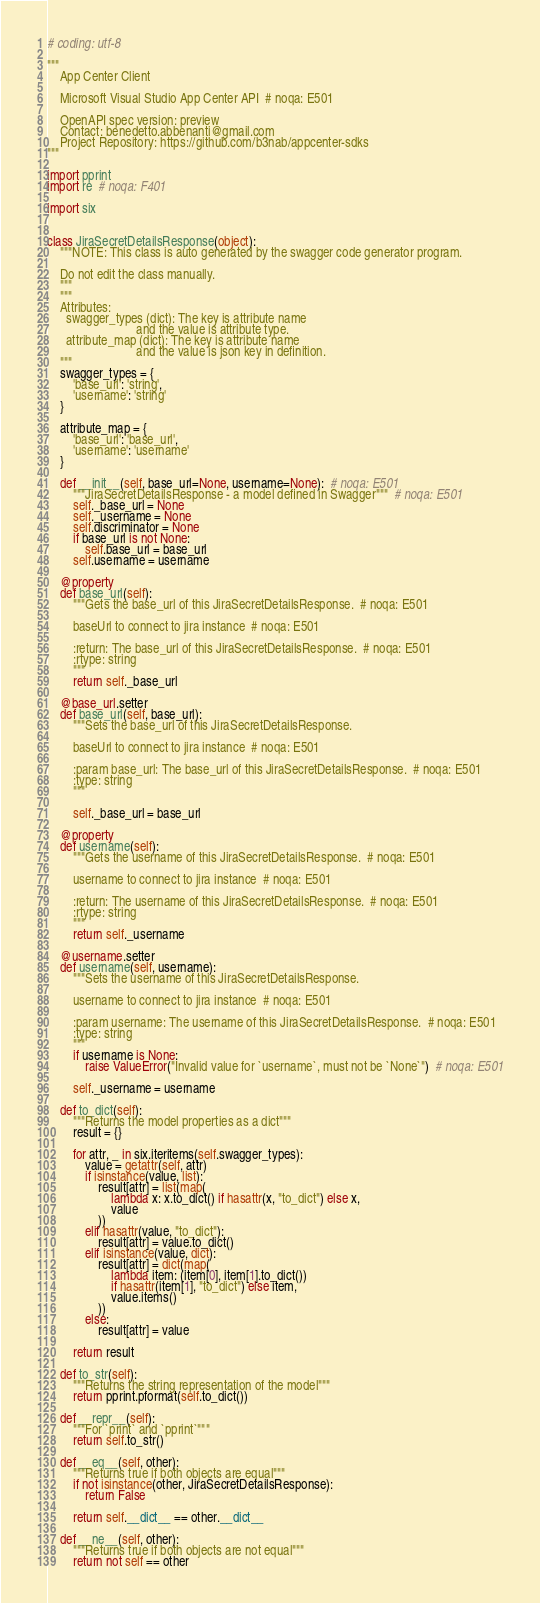<code> <loc_0><loc_0><loc_500><loc_500><_Python_># coding: utf-8

"""
    App Center Client

    Microsoft Visual Studio App Center API  # noqa: E501

    OpenAPI spec version: preview
    Contact: benedetto.abbenanti@gmail.com
    Project Repository: https://github.com/b3nab/appcenter-sdks
"""

import pprint
import re  # noqa: F401

import six


class JiraSecretDetailsResponse(object):
    """NOTE: This class is auto generated by the swagger code generator program.

    Do not edit the class manually.
    """
    """
    Attributes:
      swagger_types (dict): The key is attribute name
                            and the value is attribute type.
      attribute_map (dict): The key is attribute name
                            and the value is json key in definition.
    """
    swagger_types = {
        'base_url': 'string',
        'username': 'string'
    }

    attribute_map = {
        'base_url': 'base_url',
        'username': 'username'
    }

    def __init__(self, base_url=None, username=None):  # noqa: E501
        """JiraSecretDetailsResponse - a model defined in Swagger"""  # noqa: E501
        self._base_url = None
        self._username = None
        self.discriminator = None
        if base_url is not None:
            self.base_url = base_url
        self.username = username

    @property
    def base_url(self):
        """Gets the base_url of this JiraSecretDetailsResponse.  # noqa: E501

        baseUrl to connect to jira instance  # noqa: E501

        :return: The base_url of this JiraSecretDetailsResponse.  # noqa: E501
        :rtype: string
        """
        return self._base_url

    @base_url.setter
    def base_url(self, base_url):
        """Sets the base_url of this JiraSecretDetailsResponse.

        baseUrl to connect to jira instance  # noqa: E501

        :param base_url: The base_url of this JiraSecretDetailsResponse.  # noqa: E501
        :type: string
        """

        self._base_url = base_url

    @property
    def username(self):
        """Gets the username of this JiraSecretDetailsResponse.  # noqa: E501

        username to connect to jira instance  # noqa: E501

        :return: The username of this JiraSecretDetailsResponse.  # noqa: E501
        :rtype: string
        """
        return self._username

    @username.setter
    def username(self, username):
        """Sets the username of this JiraSecretDetailsResponse.

        username to connect to jira instance  # noqa: E501

        :param username: The username of this JiraSecretDetailsResponse.  # noqa: E501
        :type: string
        """
        if username is None:
            raise ValueError("Invalid value for `username`, must not be `None`")  # noqa: E501

        self._username = username

    def to_dict(self):
        """Returns the model properties as a dict"""
        result = {}

        for attr, _ in six.iteritems(self.swagger_types):
            value = getattr(self, attr)
            if isinstance(value, list):
                result[attr] = list(map(
                    lambda x: x.to_dict() if hasattr(x, "to_dict") else x,
                    value
                ))
            elif hasattr(value, "to_dict"):
                result[attr] = value.to_dict()
            elif isinstance(value, dict):
                result[attr] = dict(map(
                    lambda item: (item[0], item[1].to_dict())
                    if hasattr(item[1], "to_dict") else item,
                    value.items()
                ))
            else:
                result[attr] = value

        return result

    def to_str(self):
        """Returns the string representation of the model"""
        return pprint.pformat(self.to_dict())

    def __repr__(self):
        """For `print` and `pprint`"""
        return self.to_str()

    def __eq__(self, other):
        """Returns true if both objects are equal"""
        if not isinstance(other, JiraSecretDetailsResponse):
            return False

        return self.__dict__ == other.__dict__

    def __ne__(self, other):
        """Returns true if both objects are not equal"""
        return not self == other
</code> 